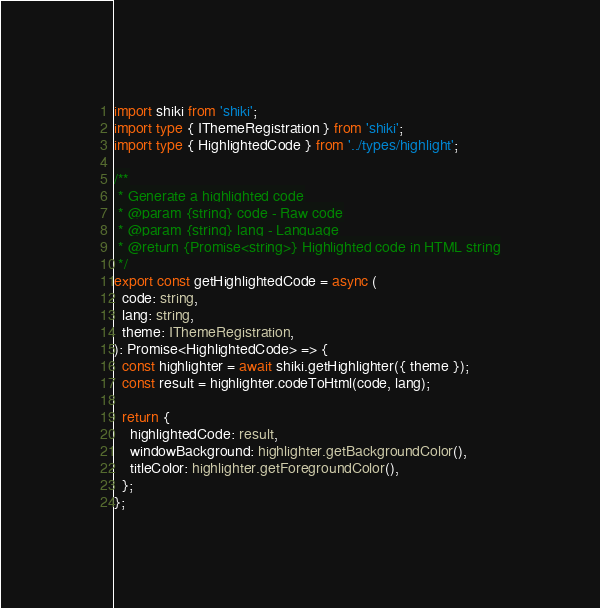<code> <loc_0><loc_0><loc_500><loc_500><_TypeScript_>import shiki from 'shiki';
import type { IThemeRegistration } from 'shiki';
import type { HighlightedCode } from '../types/highlight';

/**
 * Generate a highlighted code
 * @param {string} code - Raw code
 * @param {string} lang - Language
 * @return {Promise<string>} Highlighted code in HTML string
 */
export const getHighlightedCode = async (
  code: string,
  lang: string,
  theme: IThemeRegistration,
): Promise<HighlightedCode> => {
  const highlighter = await shiki.getHighlighter({ theme });
  const result = highlighter.codeToHtml(code, lang);

  return {
    highlightedCode: result,
    windowBackground: highlighter.getBackgroundColor(),
    titleColor: highlighter.getForegroundColor(),
  };
};
</code> 